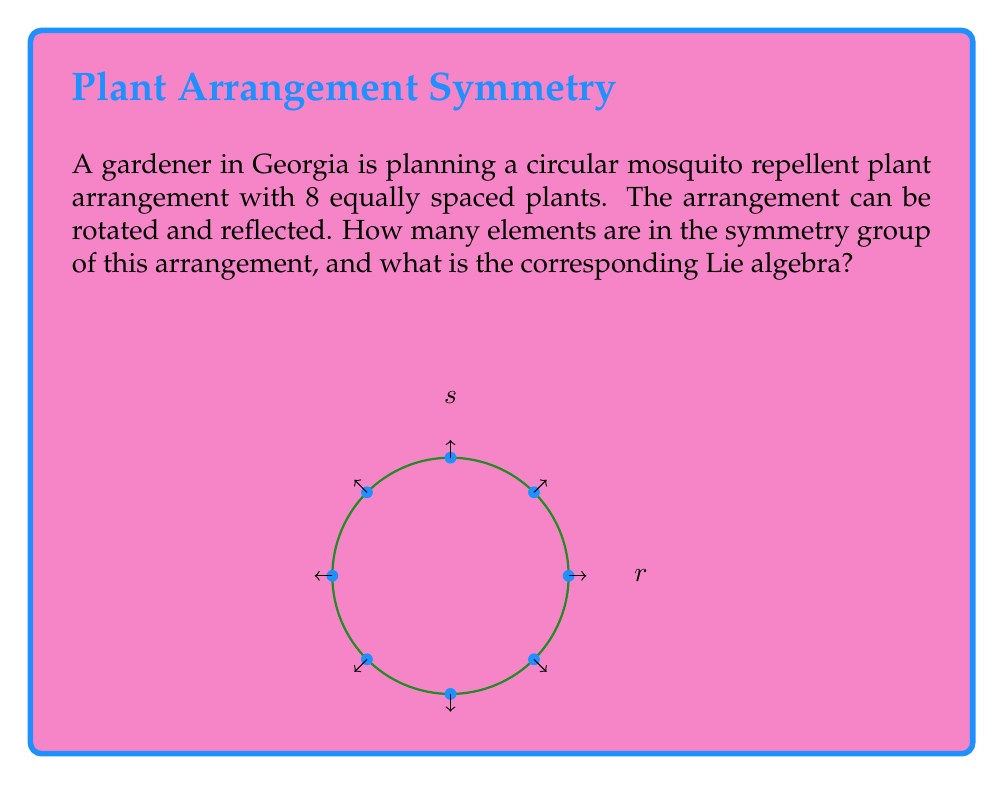Provide a solution to this math problem. Let's approach this step-by-step:

1) First, we need to identify the symmetries of the arrangement:
   - Rotations: The arrangement can be rotated by multiples of 45° (360°/8). There are 8 such rotations including the identity.
   - Reflections: There are 8 lines of reflection (4 through opposite plants and 4 between adjacent plants).

2) The total number of symmetries is thus 8 (rotations) + 8 (reflections) = 16.

3) This symmetry group is known as the dihedral group $D_8$. In general, $D_n$ has $2n$ elements.

4) The Lie algebra corresponding to $D_8$ is not a simple Lie algebra, but rather a direct sum of two simple Lie algebras:

   $$\mathfrak{d}_8 \cong \mathfrak{so}(2) \oplus \mathfrak{so}(2)$$

   Where $\mathfrak{so}(2)$ is the special orthogonal Lie algebra in 2 dimensions.

5) The reason for this decomposition is that $D_8$ can be seen as a subgroup of $O(2) \times O(2)$, where $O(2)$ is the 2-dimensional orthogonal group.

6) The dimension of this Lie algebra is 2, corresponding to the two independent rotations in the two $\mathfrak{so}(2)$ components.
Answer: 16 elements; $\mathfrak{so}(2) \oplus \mathfrak{so}(2)$ 